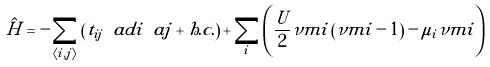<formula> <loc_0><loc_0><loc_500><loc_500>\hat { H } = - \sum _ { \langle i , j \rangle } \left ( t _ { i j } \ a d i \ a j + h . c . \right ) + \sum _ { i } \left ( \frac { U } { 2 } \nu m i \left ( \nu m i - 1 \right ) - \mu _ { i } \nu m i \right )</formula> 